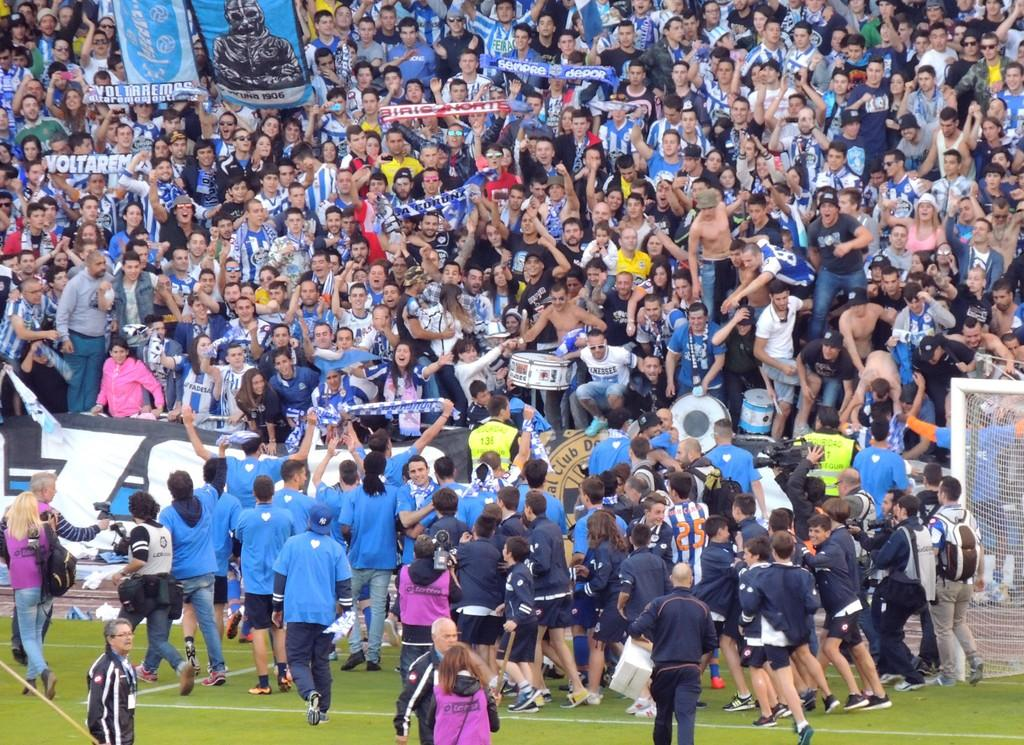<image>
Share a concise interpretation of the image provided. A player in blue and white stripes wearing number 25 celebrates with teammates and fans. 